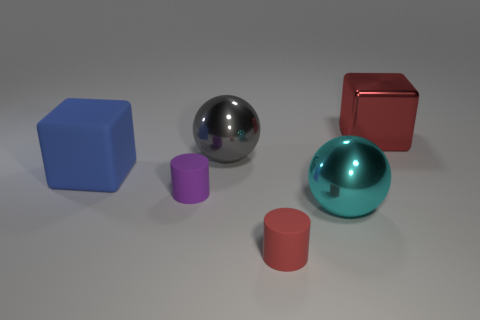There is a gray object that is the same material as the large cyan sphere; what shape is it?
Give a very brief answer. Sphere. How many tiny things are the same shape as the big red shiny thing?
Provide a short and direct response. 0. There is a big metallic object in front of the large blue rubber cube; is it the same shape as the red thing behind the blue cube?
Offer a very short reply. No. What number of things are tiny purple spheres or big balls that are in front of the big matte object?
Your answer should be very brief. 1. What is the shape of the tiny rubber thing that is the same color as the metal block?
Provide a succinct answer. Cylinder. What number of purple cubes are the same size as the gray metallic object?
Offer a very short reply. 0. How many cyan objects are rubber cylinders or big metallic balls?
Give a very brief answer. 1. There is a metallic thing to the right of the big metallic object that is in front of the gray thing; what is its shape?
Keep it short and to the point. Cube. There is a blue thing that is the same size as the red metallic object; what is its shape?
Keep it short and to the point. Cube. Is there a tiny rubber cylinder that has the same color as the large shiny block?
Your response must be concise. Yes. 